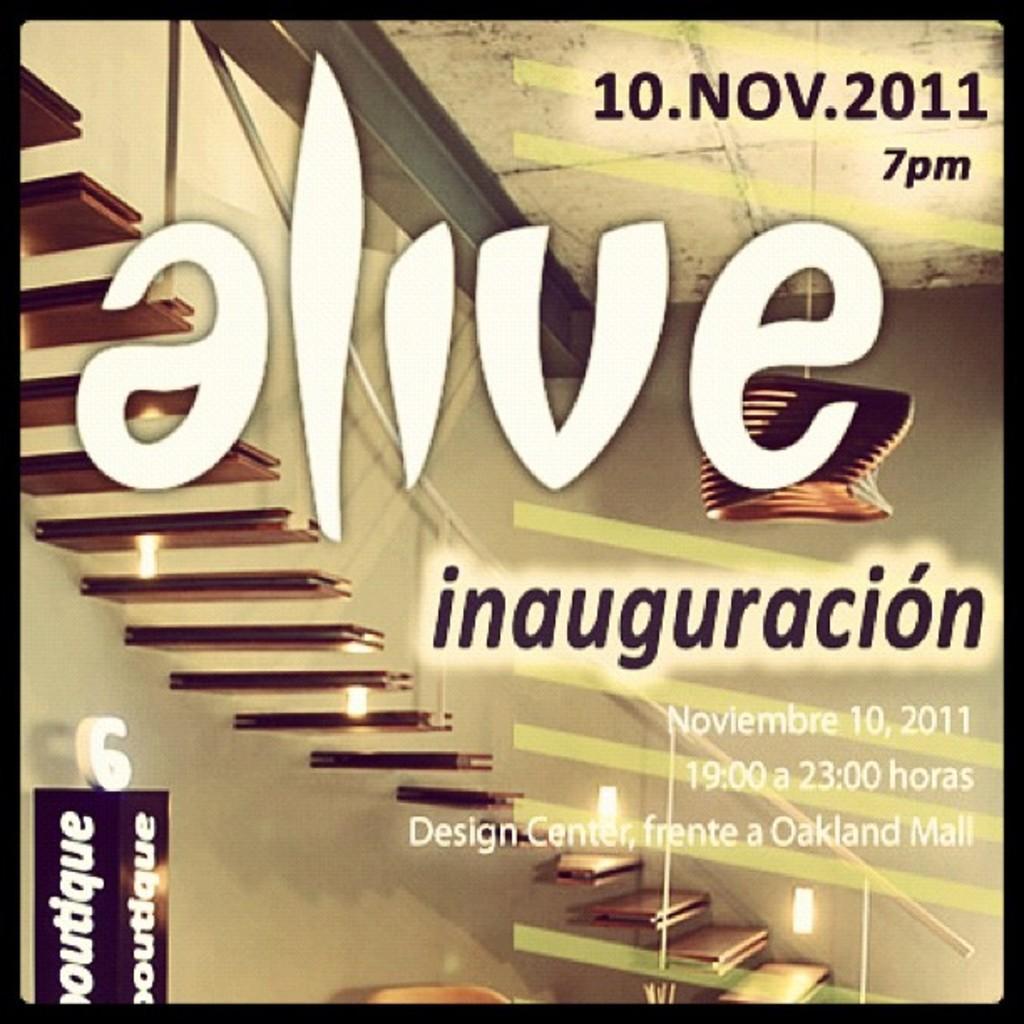Can you describe this image briefly? In this picture we can see some text and numbers on a glass object. Through this glass object, we can see a staircase, a railing and a wall in the background. 